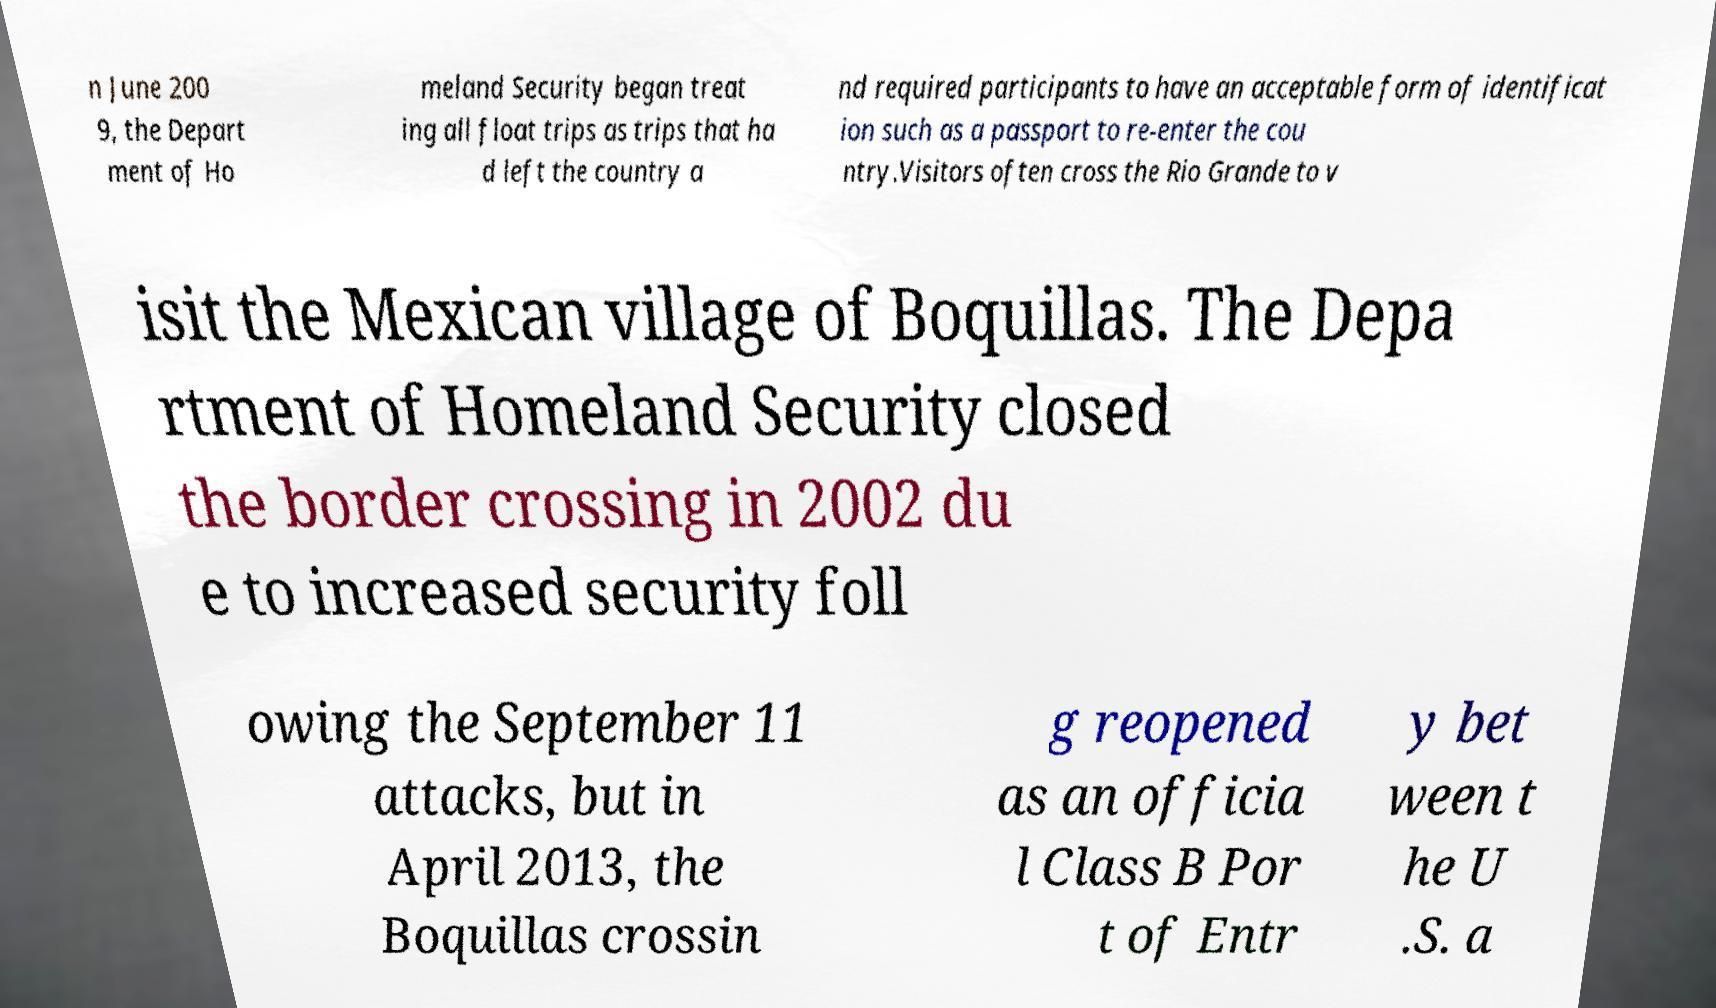Can you read and provide the text displayed in the image?This photo seems to have some interesting text. Can you extract and type it out for me? n June 200 9, the Depart ment of Ho meland Security began treat ing all float trips as trips that ha d left the country a nd required participants to have an acceptable form of identificat ion such as a passport to re-enter the cou ntry.Visitors often cross the Rio Grande to v isit the Mexican village of Boquillas. The Depa rtment of Homeland Security closed the border crossing in 2002 du e to increased security foll owing the September 11 attacks, but in April 2013, the Boquillas crossin g reopened as an officia l Class B Por t of Entr y bet ween t he U .S. a 